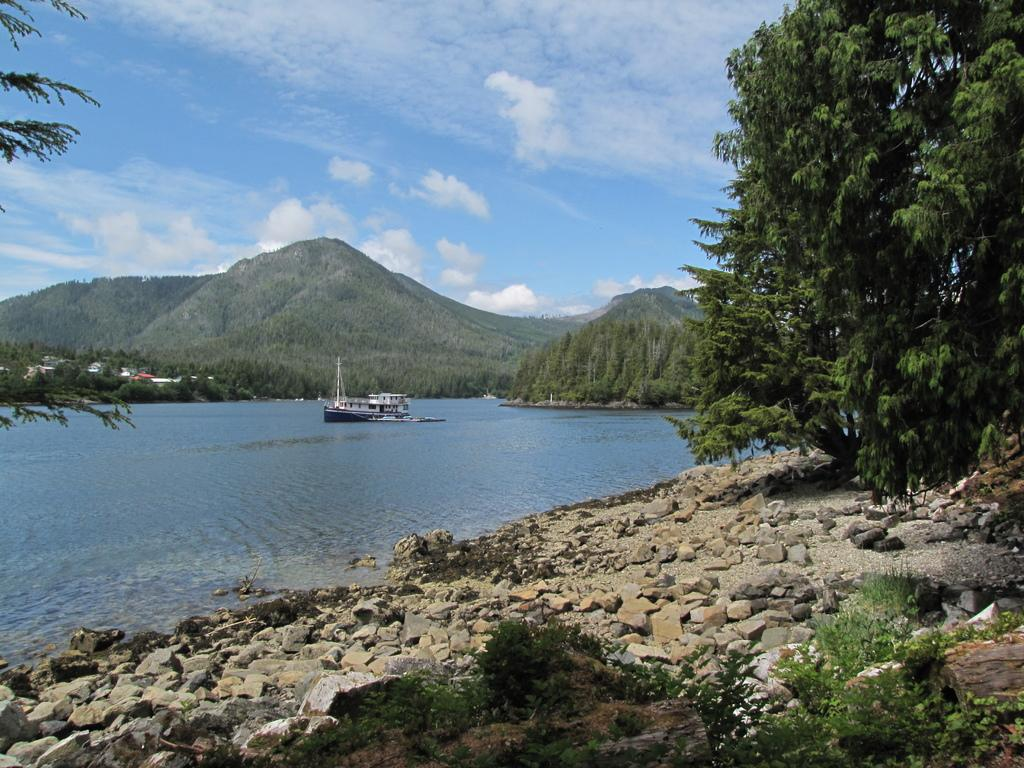What types of vegetation can be seen in the image? There are plants and trees in the image. What other objects can be seen in the image? There are stones and a ship above the water in the image. What is visible in the background of the image? Trees, hills, and the sky are visible in the background of the image. What can be seen in the sky in the image? Clouds are present in the sky. What type of sock is hanging from the tree in the image? There is no sock present in the image; it features plants, stones, trees, a ship, hills, and clouds. What scientific theory is being demonstrated by the plants in the image? The image does not depict a scientific theory; it simply shows plants, stones, trees, a ship, hills, and clouds. 